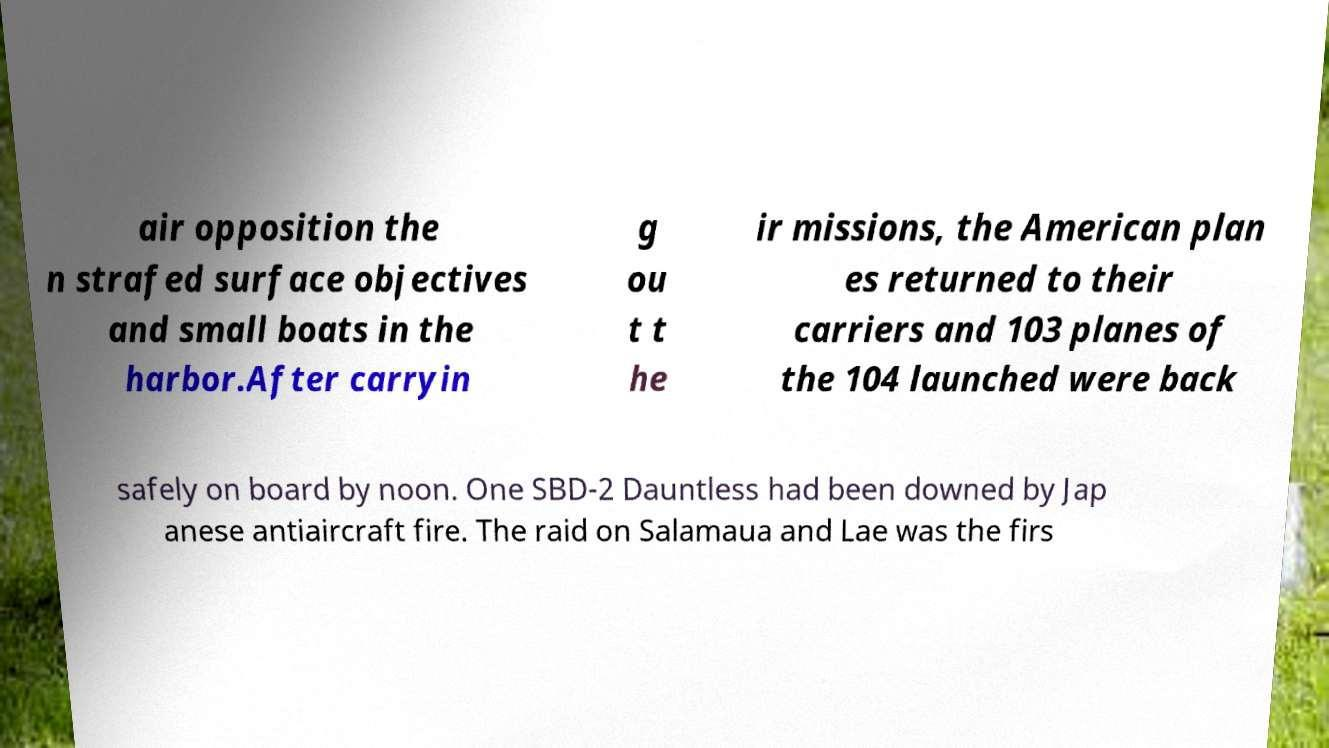What messages or text are displayed in this image? I need them in a readable, typed format. air opposition the n strafed surface objectives and small boats in the harbor.After carryin g ou t t he ir missions, the American plan es returned to their carriers and 103 planes of the 104 launched were back safely on board by noon. One SBD-2 Dauntless had been downed by Jap anese antiaircraft fire. The raid on Salamaua and Lae was the firs 